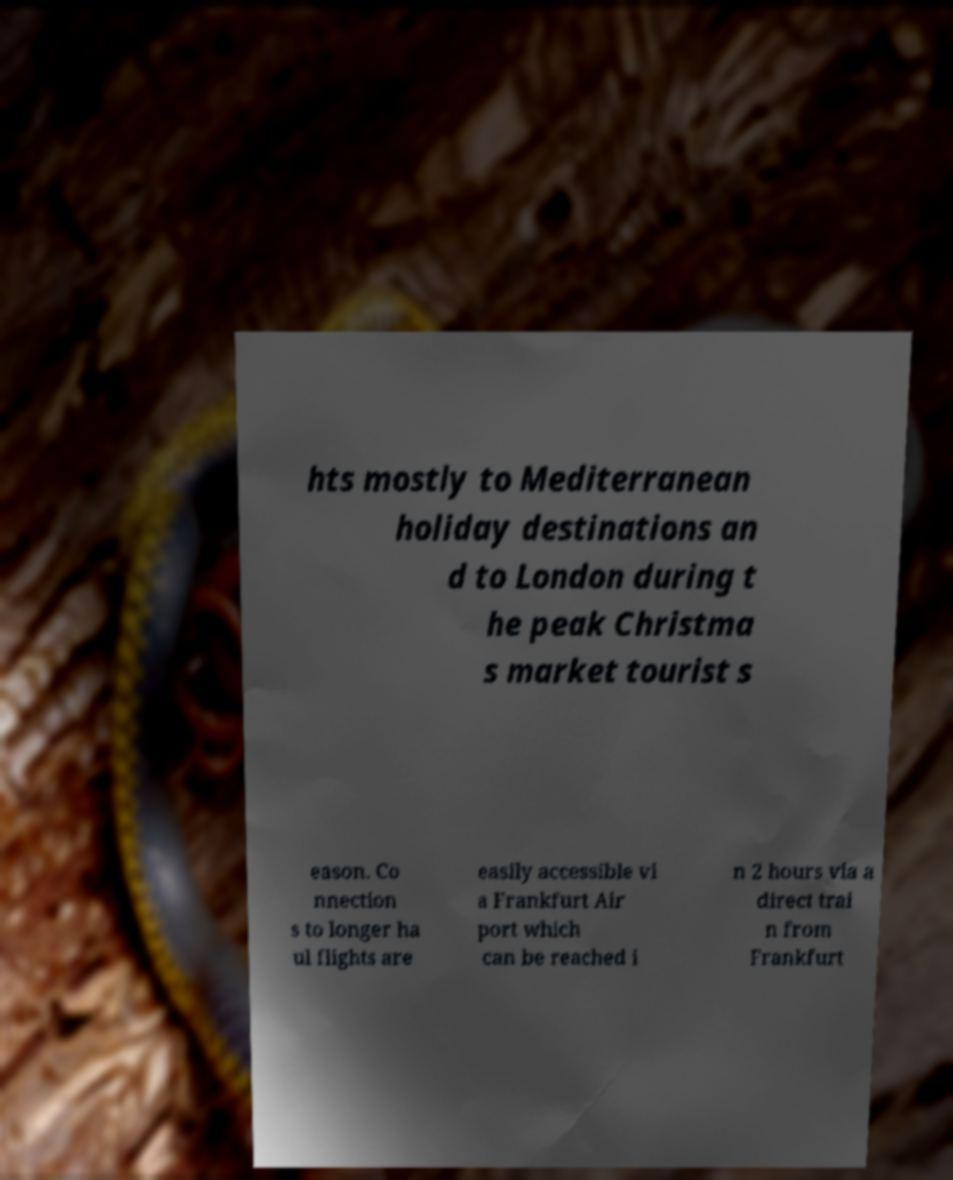Please identify and transcribe the text found in this image. hts mostly to Mediterranean holiday destinations an d to London during t he peak Christma s market tourist s eason. Co nnection s to longer ha ul flights are easily accessible vi a Frankfurt Air port which can be reached i n 2 hours via a direct trai n from Frankfurt 